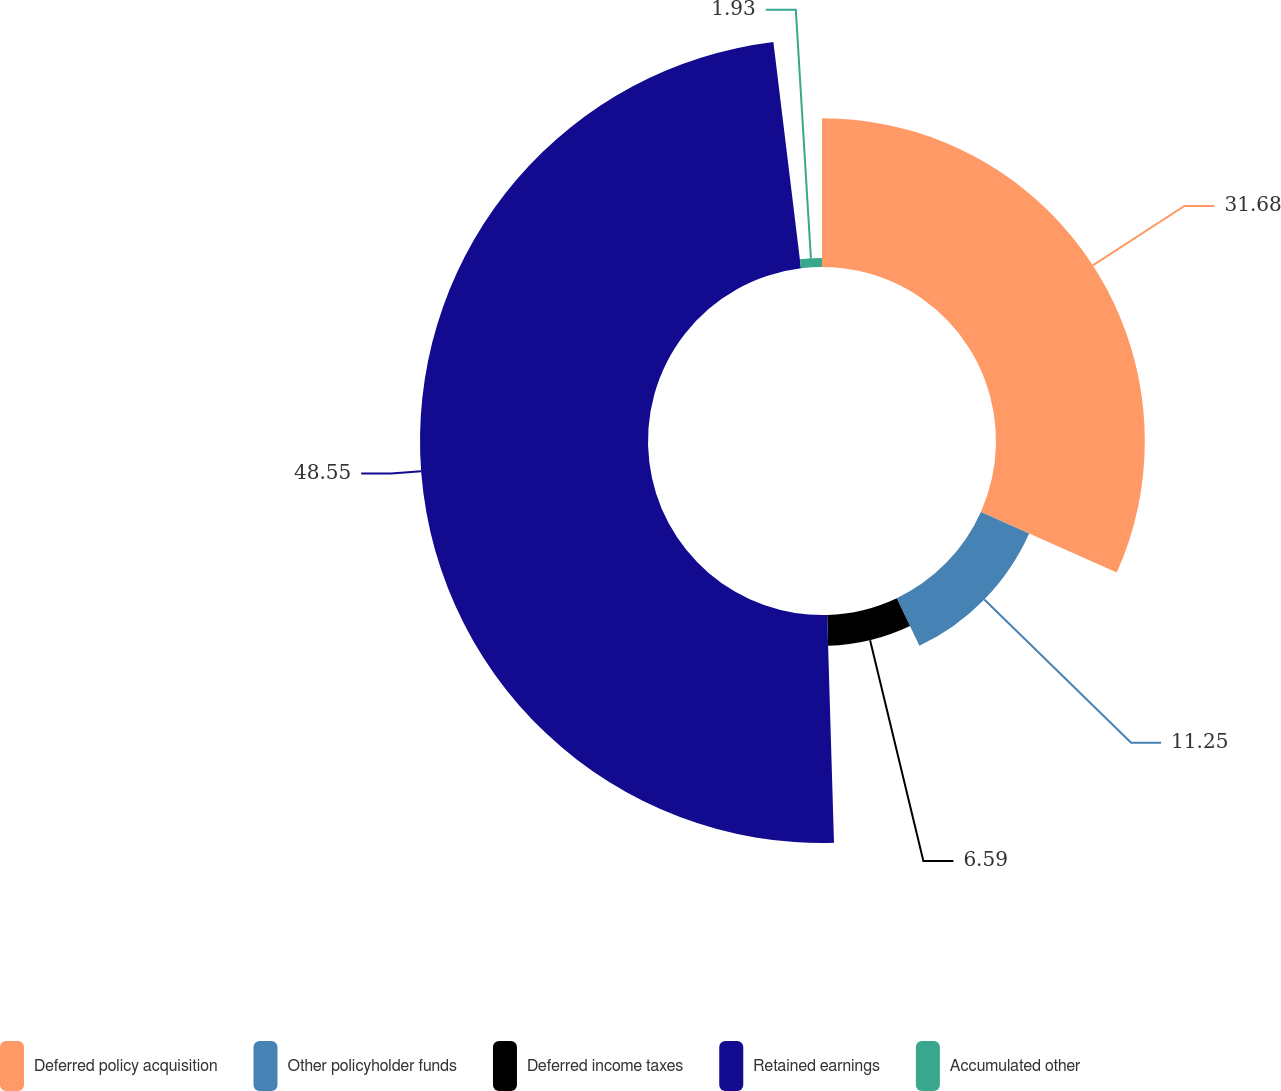Convert chart. <chart><loc_0><loc_0><loc_500><loc_500><pie_chart><fcel>Deferred policy acquisition<fcel>Other policyholder funds<fcel>Deferred income taxes<fcel>Retained earnings<fcel>Accumulated other<nl><fcel>31.68%<fcel>11.25%<fcel>6.59%<fcel>48.54%<fcel>1.93%<nl></chart> 